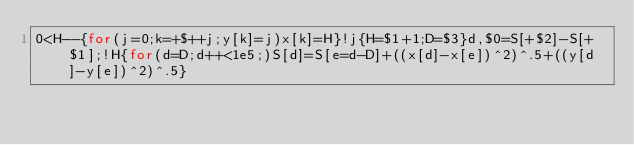<code> <loc_0><loc_0><loc_500><loc_500><_Awk_>0<H--{for(j=0;k=+$++j;y[k]=j)x[k]=H}!j{H=$1+1;D=$3}d,$0=S[+$2]-S[+$1];!H{for(d=D;d++<1e5;)S[d]=S[e=d-D]+((x[d]-x[e])^2)^.5+((y[d]-y[e])^2)^.5}</code> 